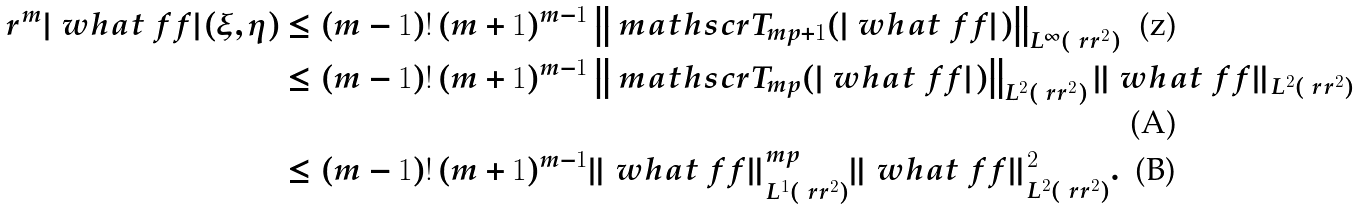Convert formula to latex. <formula><loc_0><loc_0><loc_500><loc_500>r ^ { m } | \ w h a t { \ f f } | ( \xi , \eta ) & \leq ( m - 1 ) ! \, ( m + 1 ) ^ { m - 1 } \left \| \ m a t h s c r { T } _ { m p + 1 } ( | \ w h a t { \ f f } | ) \right \| _ { L ^ { \infty } ( \ r r ^ { 2 } ) } \\ & \leq ( m - 1 ) ! \, ( m + 1 ) ^ { m - 1 } \left \| \ m a t h s c r { T } _ { m p } ( | \ w h a t { \ f f } | ) \right \| _ { L ^ { 2 } ( \ r r ^ { 2 } ) } \| \ w h a t { \ f f } \| _ { L ^ { 2 } ( \ r r ^ { 2 } ) } \\ & \leq ( m - 1 ) ! \, ( m + 1 ) ^ { m - 1 } \| \ w h a t { \ f f } \| _ { L ^ { 1 } ( \ r r ^ { 2 } ) } ^ { m p } \| \ w h a t { \ f f } \| _ { L ^ { 2 } ( \ r r ^ { 2 } ) } ^ { 2 } .</formula> 